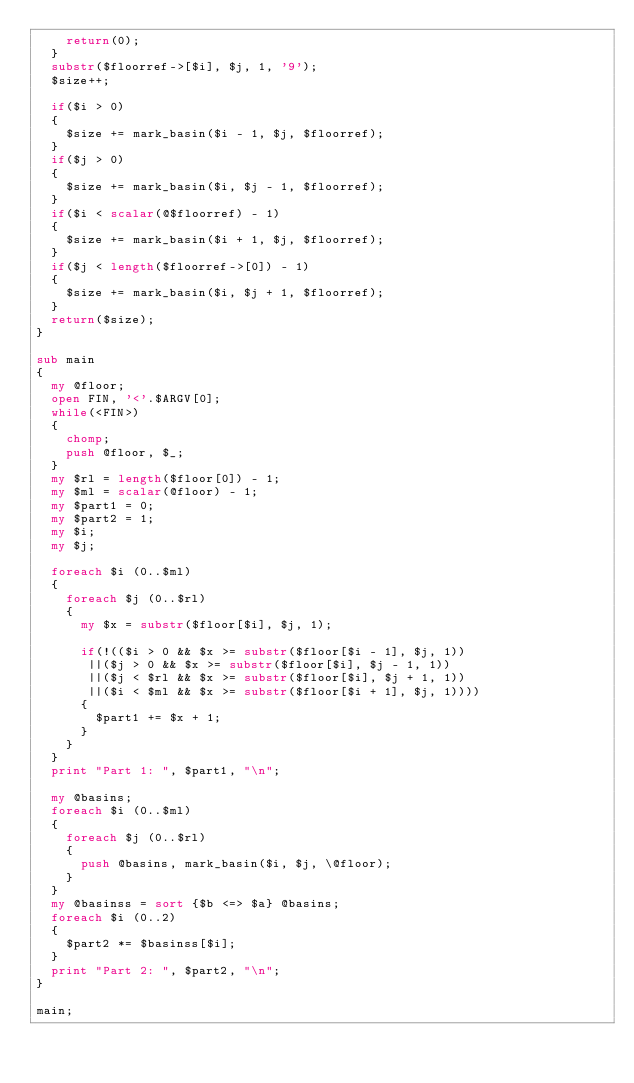<code> <loc_0><loc_0><loc_500><loc_500><_Perl_>    return(0);
  }
  substr($floorref->[$i], $j, 1, '9');
  $size++;

  if($i > 0)
  {
    $size += mark_basin($i - 1, $j, $floorref);
  }
  if($j > 0)
  {
    $size += mark_basin($i, $j - 1, $floorref);
  }
  if($i < scalar(@$floorref) - 1)
  {
    $size += mark_basin($i + 1, $j, $floorref);
  }
  if($j < length($floorref->[0]) - 1)
  {
    $size += mark_basin($i, $j + 1, $floorref);
  }
  return($size);
}

sub main
{
  my @floor;
  open FIN, '<'.$ARGV[0];
  while(<FIN>)
  {
    chomp;
    push @floor, $_;
  }
  my $rl = length($floor[0]) - 1;
  my $ml = scalar(@floor) - 1;
  my $part1 = 0;
  my $part2 = 1;
  my $i;
  my $j;

  foreach $i (0..$ml)
  {
    foreach $j (0..$rl)
    {
      my $x = substr($floor[$i], $j, 1);

      if(!(($i > 0 && $x >= substr($floor[$i - 1], $j, 1))
       ||($j > 0 && $x >= substr($floor[$i], $j - 1, 1))
       ||($j < $rl && $x >= substr($floor[$i], $j + 1, 1))
       ||($i < $ml && $x >= substr($floor[$i + 1], $j, 1))))
      {
        $part1 += $x + 1;
      }
    }
  }
  print "Part 1: ", $part1, "\n";

  my @basins;
  foreach $i (0..$ml)
  {
    foreach $j (0..$rl)
    {
      push @basins, mark_basin($i, $j, \@floor);
    }
  }
  my @basinss = sort {$b <=> $a} @basins;
  foreach $i (0..2)
  {
    $part2 *= $basinss[$i];
  }
  print "Part 2: ", $part2, "\n";
}

main;
</code> 